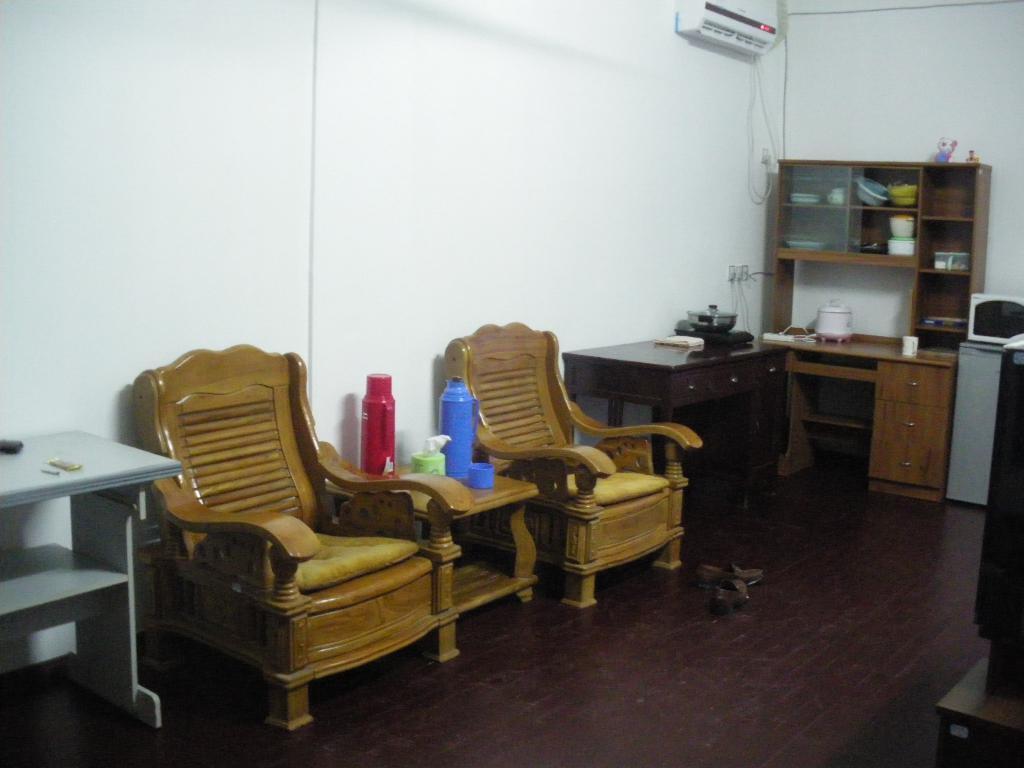Please provide a concise description of this image. In this image on the left, there are two chairs, tables, bottles, vessels,shelves, air conditioner, cupboards, wall, floor. On the right there is micro oven, table. 